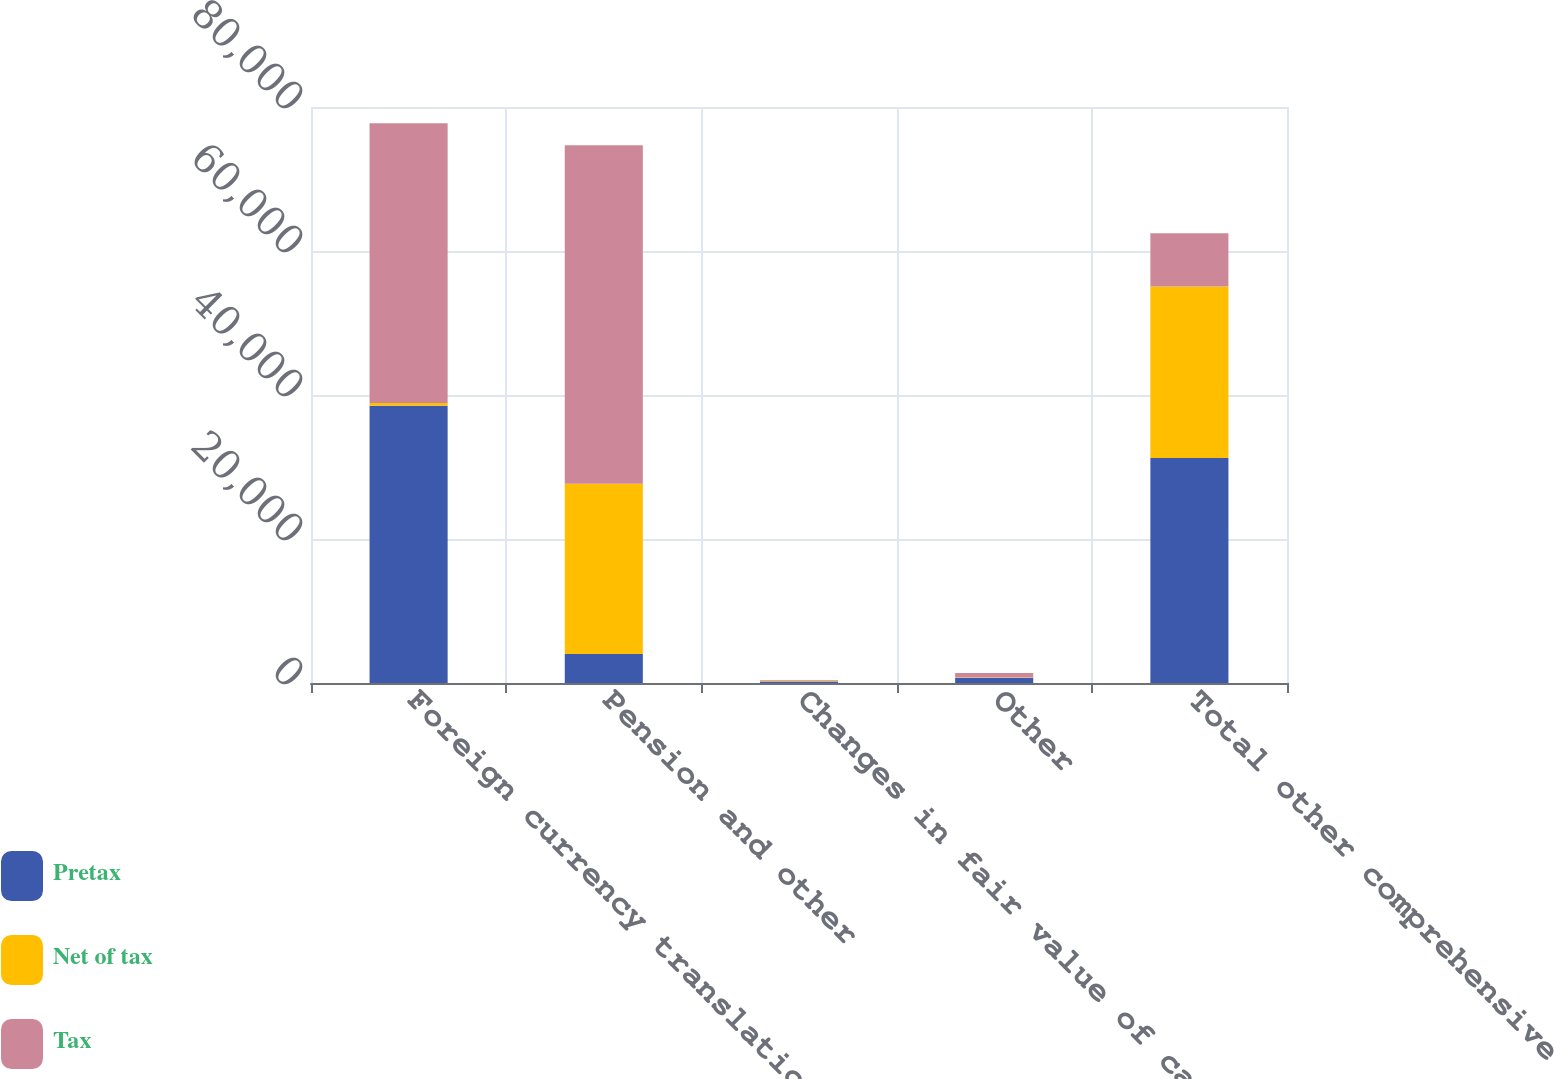Convert chart. <chart><loc_0><loc_0><loc_500><loc_500><stacked_bar_chart><ecel><fcel>Foreign currency translation<fcel>Pension and other<fcel>Changes in fair value of cash<fcel>Other<fcel>Total other comprehensive<nl><fcel>Pretax<fcel>38521<fcel>4044<fcel>195<fcel>692<fcel>31234<nl><fcel>Net of tax<fcel>359<fcel>23632<fcel>70<fcel>83<fcel>23838<nl><fcel>Tax<fcel>38880<fcel>47010<fcel>125<fcel>609<fcel>7396<nl></chart> 